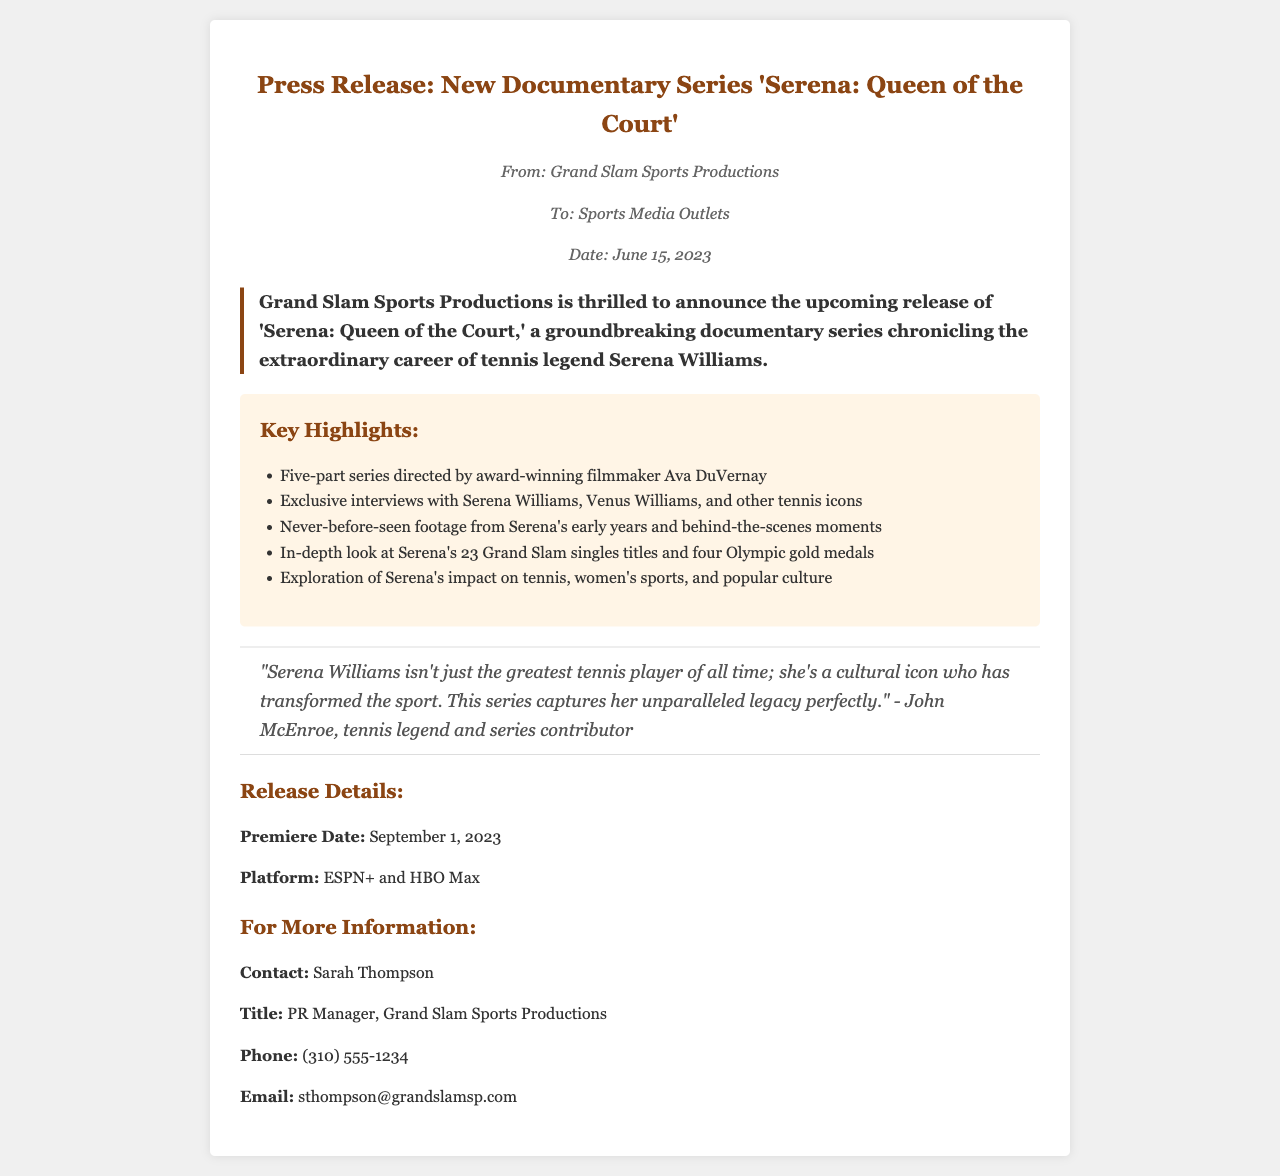What is the title of the documentary series? The title of the documentary series is mentioned in the header of the document.
Answer: 'Serena: Queen of the Court' Who directed the documentary series? The director of the series is referenced in the key highlights section.
Answer: Ava DuVernay When is the premiere date of the series? The premiere date is indicated in the release details section of the document.
Answer: September 1, 2023 How many Grand Slam singles titles did Serena Williams win? The number of Grand Slam singles titles won by Serena is included in the key highlights.
Answer: 23 What platforms will the series be available on? The platforms for the series are listed in the release details section.
Answer: ESPN+ and HBO Max Who provided a quote in the press release? The individual providing the quote is mentioned within a specific quote section.
Answer: John McEnroe What type of series is being released? The document states the format of the series in the introduction.
Answer: Documentary series What is the name of the PR Manager mentioned in the document? The name of the PR Manager is found in the contact information section.
Answer: Sarah Thompson 